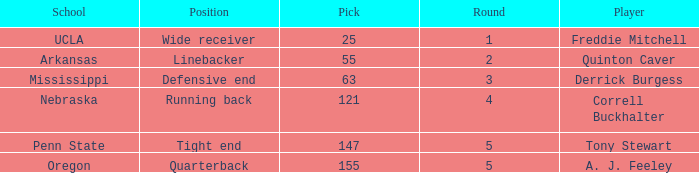What position did a. j. feeley play who was picked in round 5? Quarterback. 